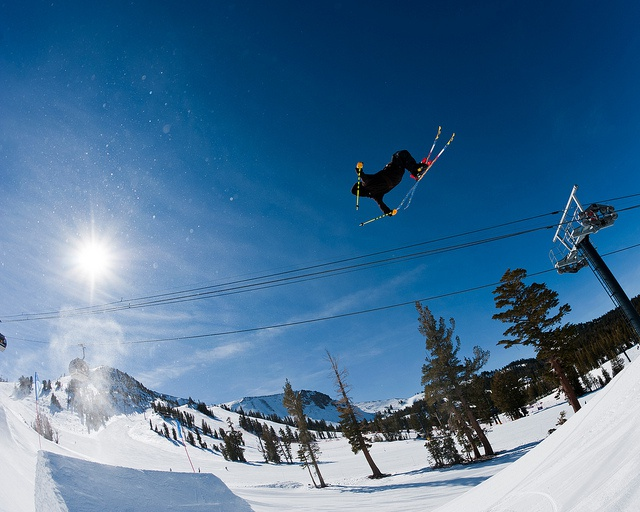Describe the objects in this image and their specific colors. I can see people in darkblue, black, navy, orange, and gray tones and skis in darkblue, navy, blue, and gray tones in this image. 